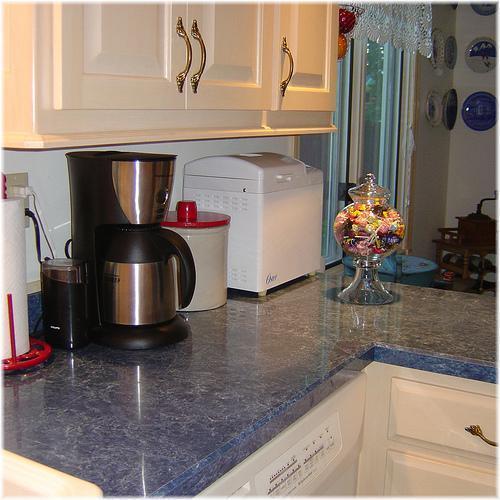How many sinks are there?
Give a very brief answer. 1. 